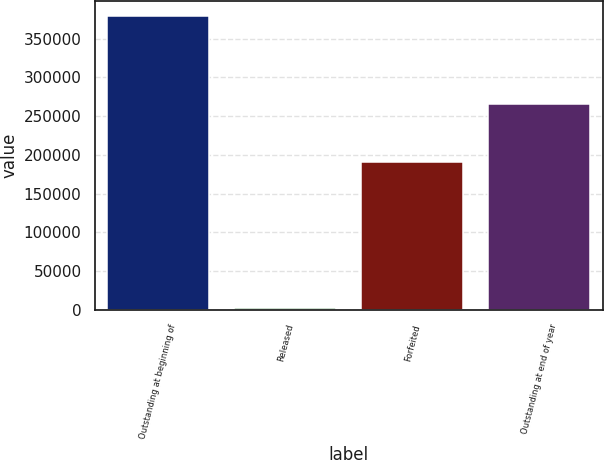Convert chart to OTSL. <chart><loc_0><loc_0><loc_500><loc_500><bar_chart><fcel>Outstanding at beginning of<fcel>Released<fcel>Forfeited<fcel>Outstanding at end of year<nl><fcel>379226<fcel>2029<fcel>190873<fcel>265747<nl></chart> 